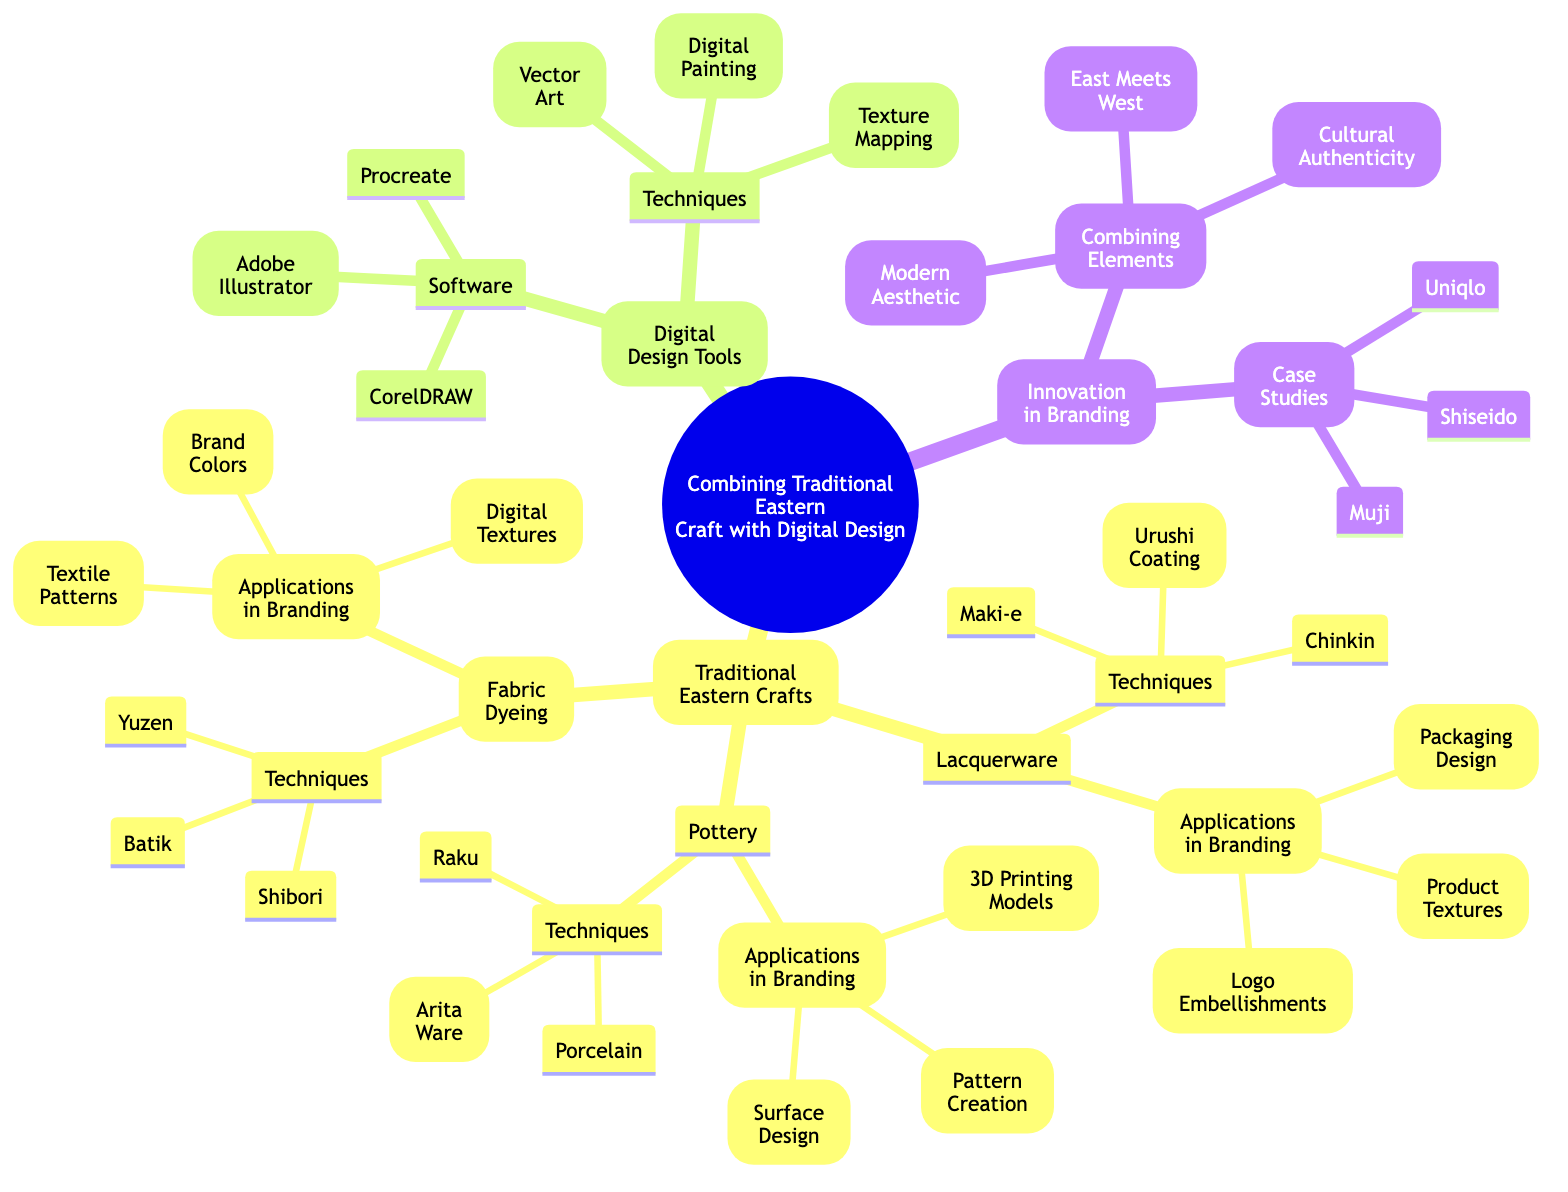What traditional craft techniques are listed under Lacquerware? The diagram contains three techniques under Lacquerware: Urushi Coating, Maki-e, and Chinkin. These are mentioned in the subnodes of Lacquerware.
Answer: Urushi Coating, Maki-e, Chinkin How many digital design software tools are mentioned in the diagram? Under the Digital Design Tools section, there are three software tools listed: Adobe Illustrator, CorelDRAW, and Procreate. This is counted in the subnodes of Software.
Answer: 3 What are the applications of Fabric Dyeing in branding? The diagram lists three applications of Fabric Dyeing in branding: Textile Patterns, Brand Colors, and Digital Textures. These are specifically mentioned in the Applications in Branding subnodes of Fabric Dyeing.
Answer: Textile Patterns, Brand Colors, Digital Textures Which traditional craft technique requires surface design applications? Pottery techniques include Surface Design as one of its applications in branding, mentioned in the Applications in Branding subnodes under Pottery.
Answer: Pottery What is the primary focus of the Innovation in Branding section? The Innovation in Branding section focuses on Combining Elements and includes three concepts: East Meets West, Modern Aesthetic, and Cultural Authenticity.  This is highlighted in the Combining Elements subnode of Innovation in Branding.
Answer: Combining Elements Which two fabric dyeing techniques are listed alongside Shibori? The diagram mentions Batik and Yuzen as the other two techniques listed alongside Shibori under Fabric Dyeing Techniques. These are part of the subnodes of Fabric Dyeing.
Answer: Batik, Yuzen What do the case studies in Innovation in Branding demonstrate? The case studies Muji, Shiseido, and Uniqlo are showcased to demonstrate real-world applications of combining traditional craft techniques with modern branding strategies, as noted under the Case Studies subnode of Innovation in Branding.
Answer: Muji, Shiseido, Uniqlo Which digital design technique is related to creating textures? The diagram lists Texture Mapping under Techniques in Digital Design Tools, indicating its relation to creating textures in digital design contexts. This is detailed in the Techniques subnode of Digital Design Tools.
Answer: Texture Mapping How do Lacquerware techniques contribute to branding? Lacquerware techniques contribute through Logo Embellishments, Packaging Design, and Product Textures, as specified under Applications in Branding for Lacquerware in the diagram.
Answer: Logo Embellishments, Packaging Design, Product Textures 